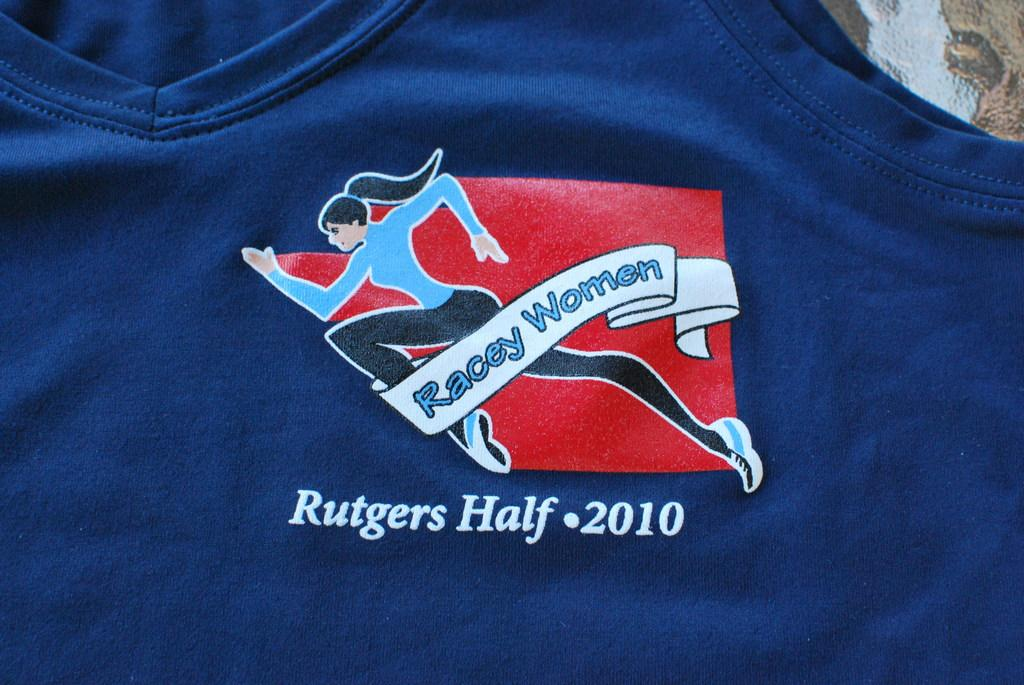<image>
Summarize the visual content of the image. A shirt that says Racey Women Rutgers Half 2010. 